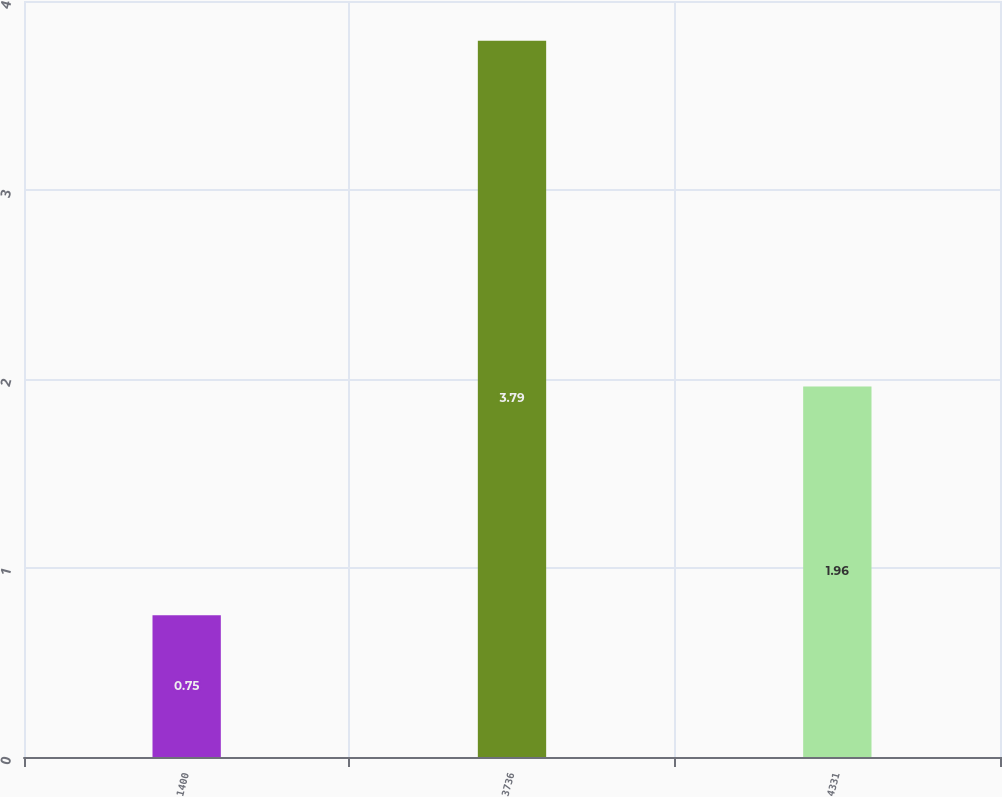Convert chart to OTSL. <chart><loc_0><loc_0><loc_500><loc_500><bar_chart><fcel>1400<fcel>3736<fcel>4331<nl><fcel>0.75<fcel>3.79<fcel>1.96<nl></chart> 